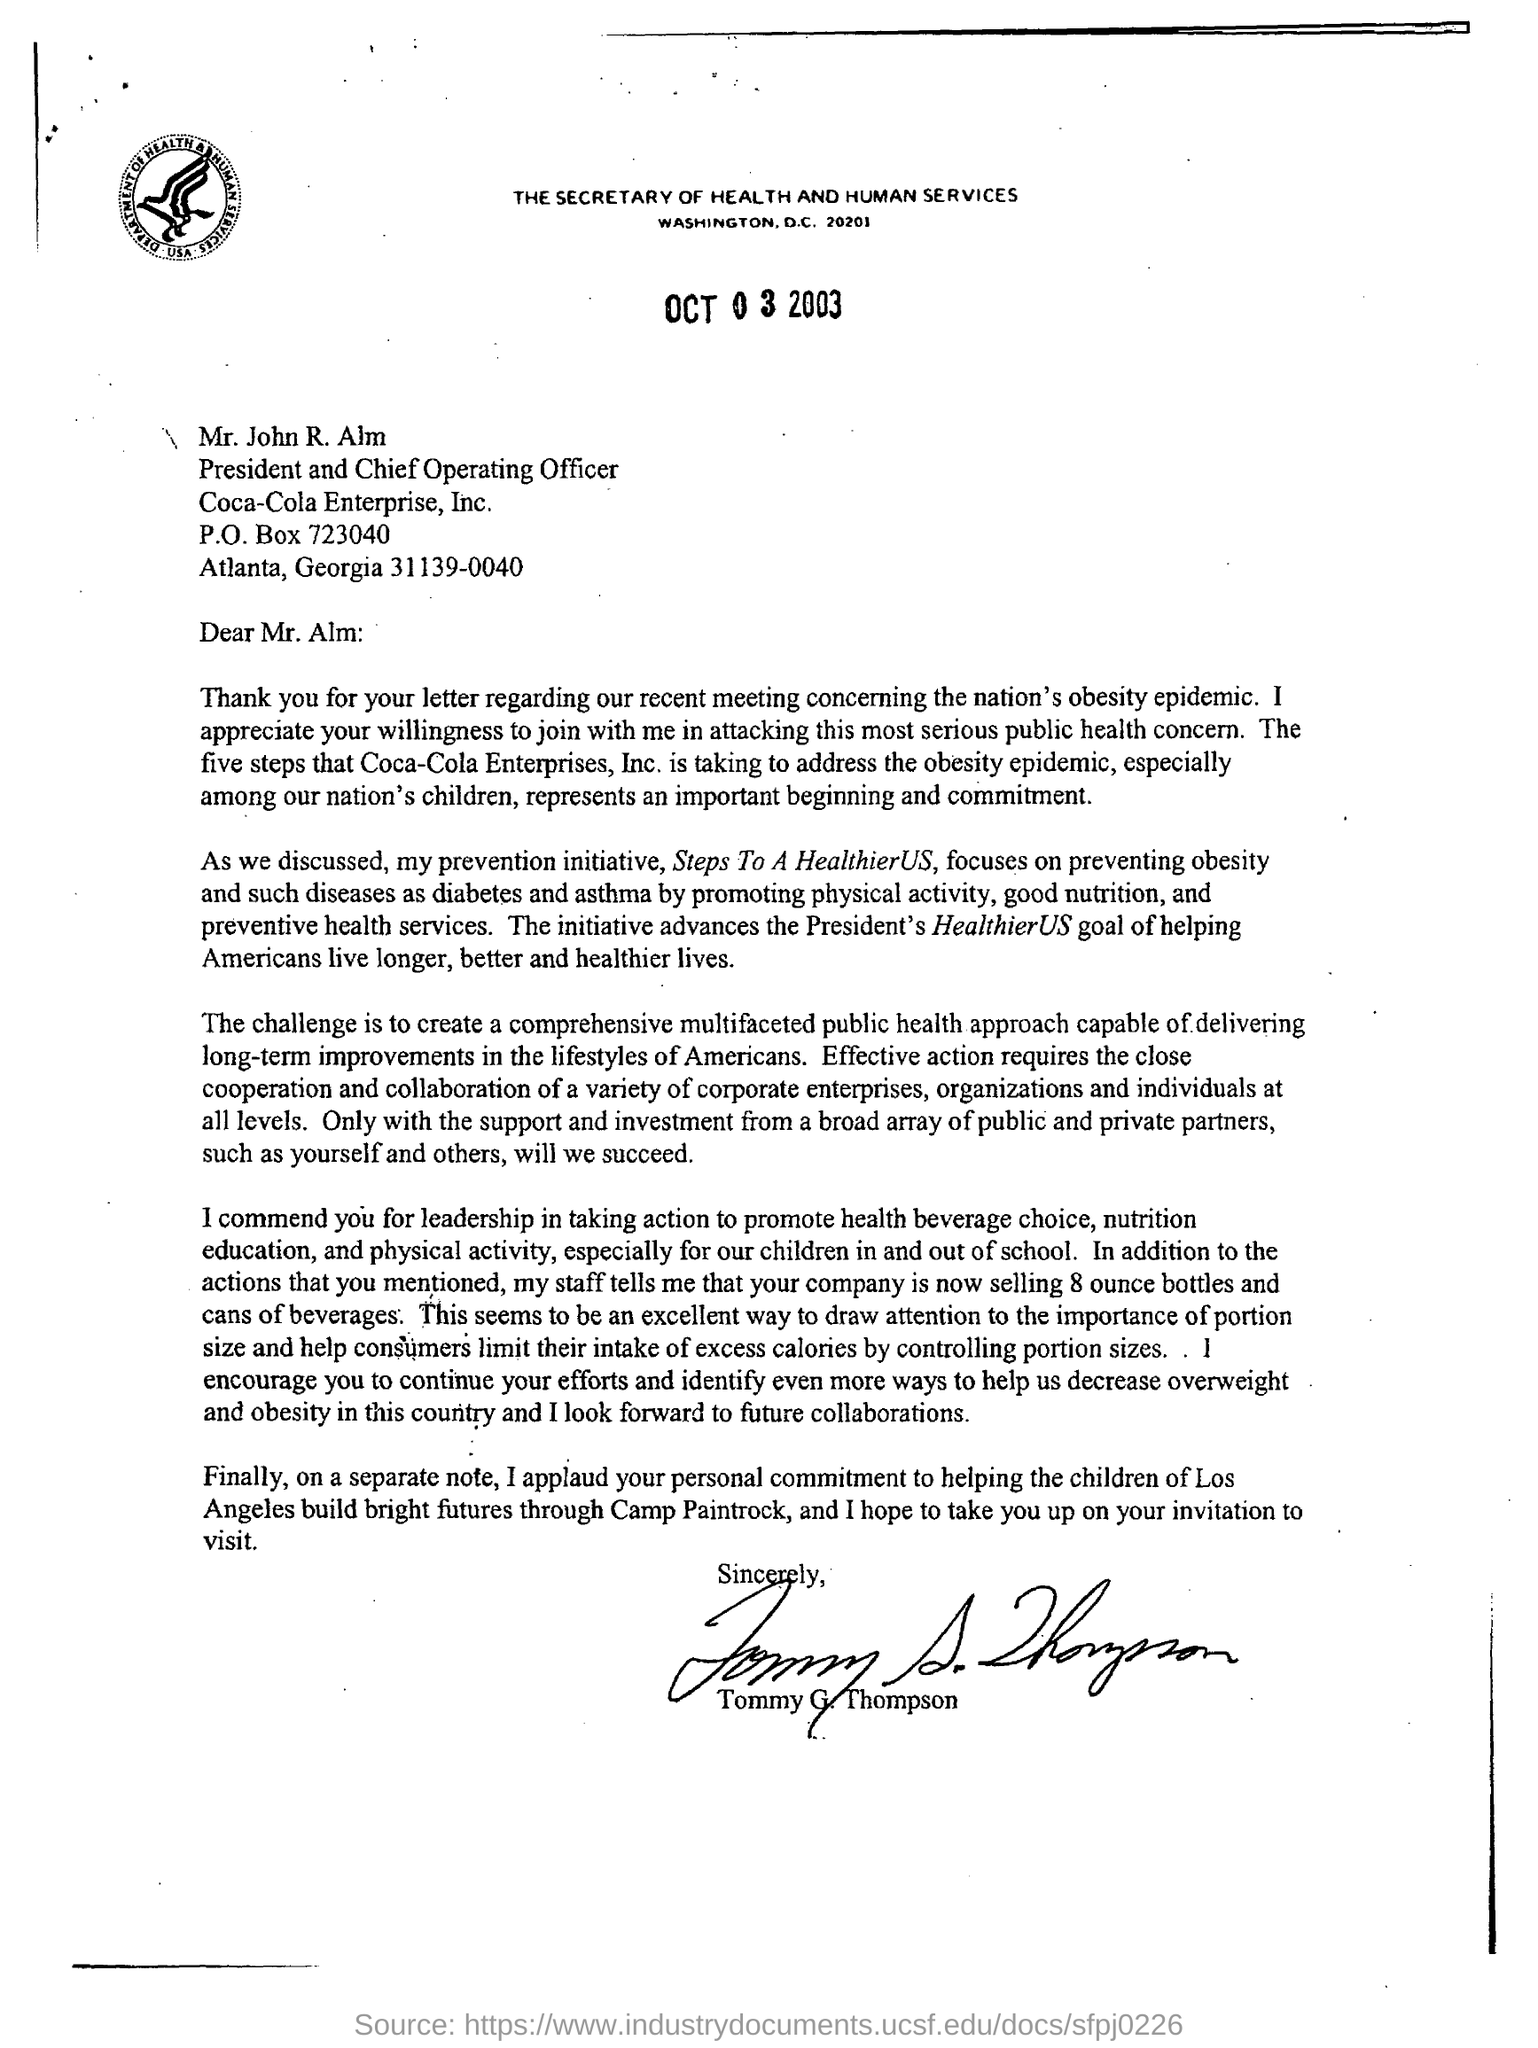Point out several critical features in this image. I applaud Alm for their personal commitment to helping the children of Los Angeles build bright futures through Camp Paintrock. The letter is addressed to Mr. Alm. Mr. John R. Alm holds the designation of both President and Chief Operating Officer. The president's healthierUS goal is to help Americans live longer, better, and healthier lives. 